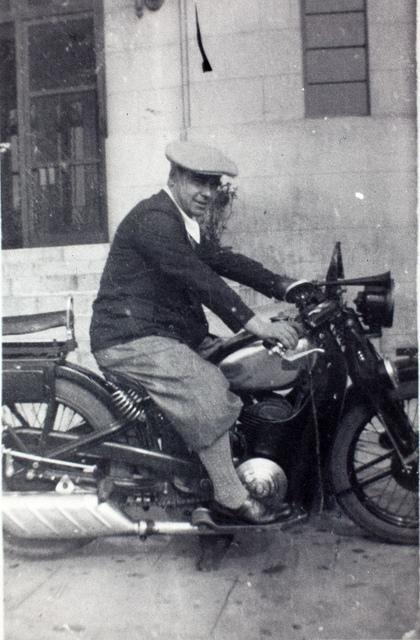How many bikes will fit on rack?
Give a very brief answer. 0. 